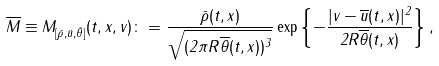Convert formula to latex. <formula><loc_0><loc_0><loc_500><loc_500>\overline { M } \equiv M _ { [ \bar { \rho } , \bar { u } , \bar { \theta } ] } ( t , x , v ) \colon = \frac { \bar { \rho } ( t , x ) } { \sqrt { ( 2 \pi R \overline { \theta } ( t , x ) ) ^ { 3 } } } \exp \left \{ - \frac { | v - \overline { u } ( t , x ) | ^ { 2 } } { 2 R \overline { \theta } ( t , x ) } \right \} ,</formula> 